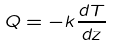Convert formula to latex. <formula><loc_0><loc_0><loc_500><loc_500>Q = - k \frac { d T } { d z }</formula> 